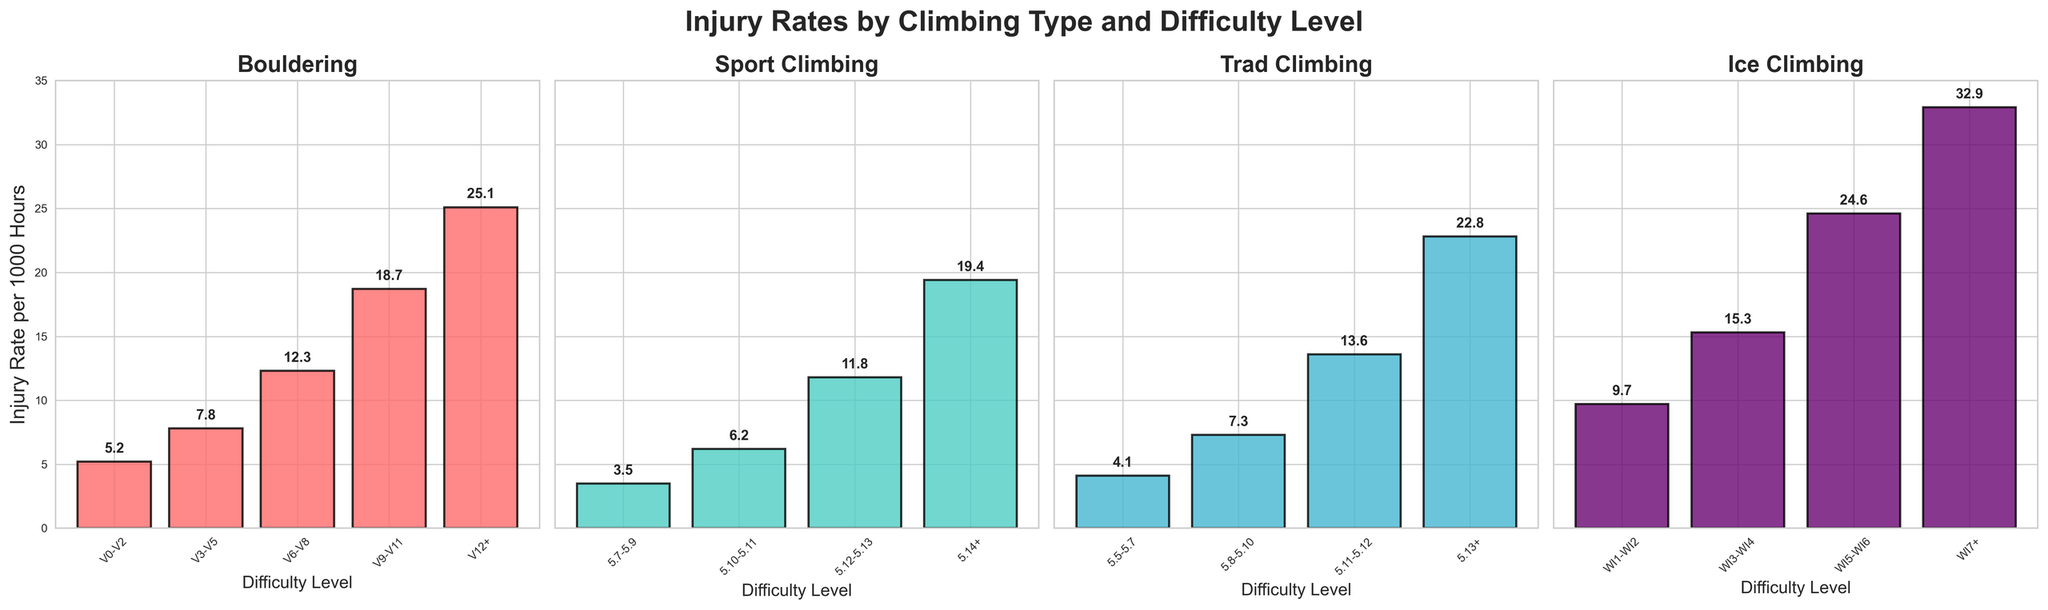What's the injury rate for V9-V11 in Bouldering? Look at the bar corresponding to the V9-V11 difficulty level in the Bouldering subplot. The height of the bar indicates the injury rate.
Answer: 18.7 What's the difference in the injury rate between WI7+ and WI3-WI4 in Ice Climbing? Find the injury rates for WI7+ and WI3-WI4 in the Ice Climbing subplot. Subtract the injury rate of WI3-WI4 (15.3) from WI7+ (32.9).
Answer: 17.6 Which climbing type has the highest injury rate at the highest difficulty level? Compare the highest injury rates in each subplot: Bouldering (V12+), Sport Climbing (5.14+), Trad Climbing (5.13+), and Ice Climbing (WI7+). The highest value of all is 32.9 for Ice Climbing (WI7+).
Answer: Ice Climbing What is the average injury rate for Sport Climbing across all difficulty levels? Sum all the injury rates for Sport Climbing (3.5 + 6.2 + 11.8 + 19.4) and divide by the number of difficulty levels (4). 40.9 / 4 = 10.225.
Answer: 10.225 Compare the injury rates of V0-V2 Bouldering and 5.7-5.9 Sport Climbing. Which is higher? Look at the bars for V0-V2 in Bouldering and 5.7-5.9 in Sport Climbing. Compare their heights. V0-V2 Bouldering has an injury rate of 5.2, while 5.7-5.9 Sport Climbing has an injury rate of 3.5.
Answer: V0-V2 Bouldering Is the injury rate for lower difficulty levels (V0-V2, 5.7-5.9, 5.5-5.7, WI1-WI2) consistently lower than higher difficulty levels (V12+, 5.14+, 5.13+, WI7+)? Compare the injury rates of the lowest difficulty levels in each subplot (5.2, 3.5, 4.1, 9.7) with those of the highest difficulty levels (25.1, 19.4, 22.8, 32.9). They are all consistently lower.
Answer: Yes How much higher is the injury rate for 5.11-5.12 in Trad Climbing compared to 5.10-5.11 in Sport Climbing? Subtract the injury rate for 5.10-5.11 in Sport Climbing (6.2) from 5.11-5.12 in Trad Climbing (13.6). 13.6 - 6.2 = 7.4.
Answer: 7.4 